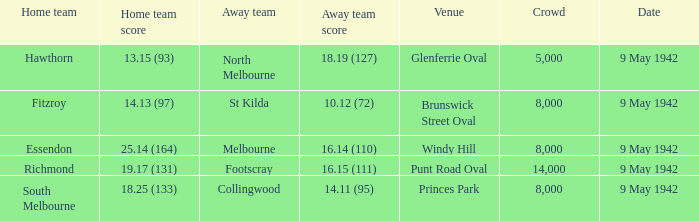How many people attended the game with the home team scoring 18.25 (133)? 1.0. 